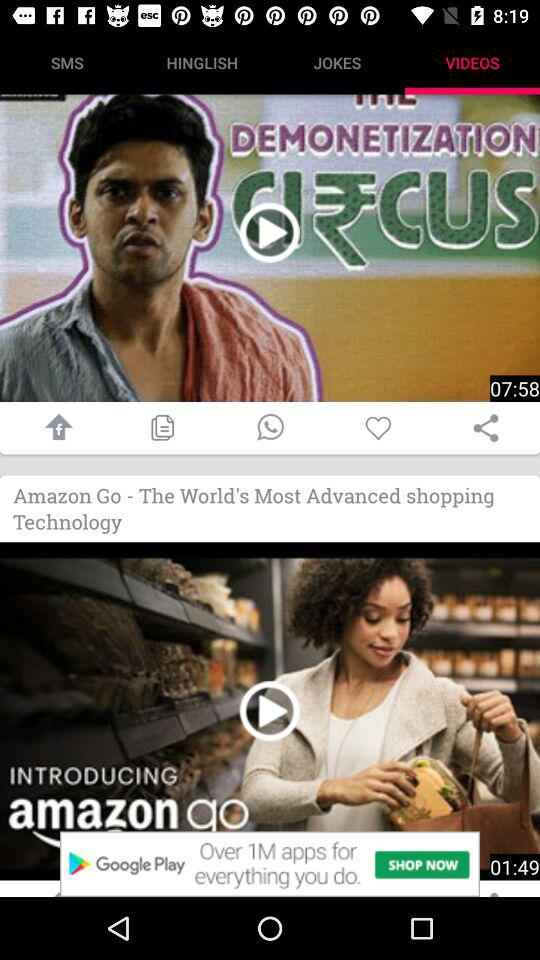How many videos are displayed?
Answer the question using a single word or phrase. 2 